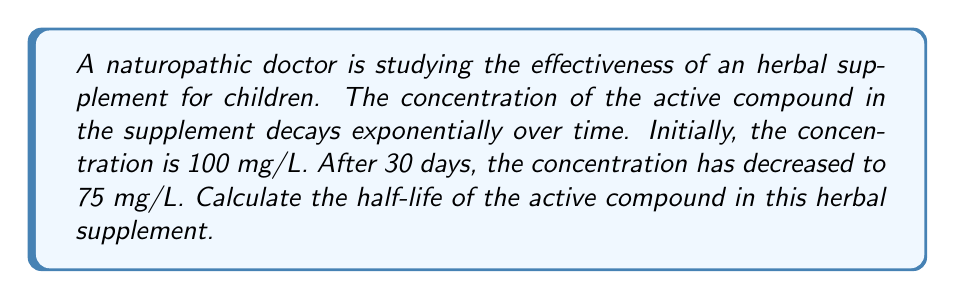What is the answer to this math problem? To solve this problem, we'll use the exponential decay function and the concept of half-life:

1) The general form of exponential decay is:
   $$A(t) = A_0 e^{-kt}$$
   where $A(t)$ is the amount at time $t$, $A_0$ is the initial amount, $k$ is the decay constant, and $t$ is time.

2) We know:
   $A_0 = 100$ mg/L
   $A(30) = 75$ mg/L
   $t = 30$ days

3) Substitute these values into the equation:
   $$75 = 100 e^{-30k}$$

4) Solve for $k$:
   $$\frac{75}{100} = e^{-30k}$$
   $$\ln(0.75) = -30k$$
   $$k = -\frac{\ln(0.75)}{30} \approx 0.00963$$

5) The formula for half-life is:
   $$t_{1/2} = \frac{\ln(2)}{k}$$

6) Substitute the value of $k$:
   $$t_{1/2} = \frac{\ln(2)}{0.00963} \approx 72.02$$

Therefore, the half-life of the active compound is approximately 72.02 days.
Answer: 72.02 days 